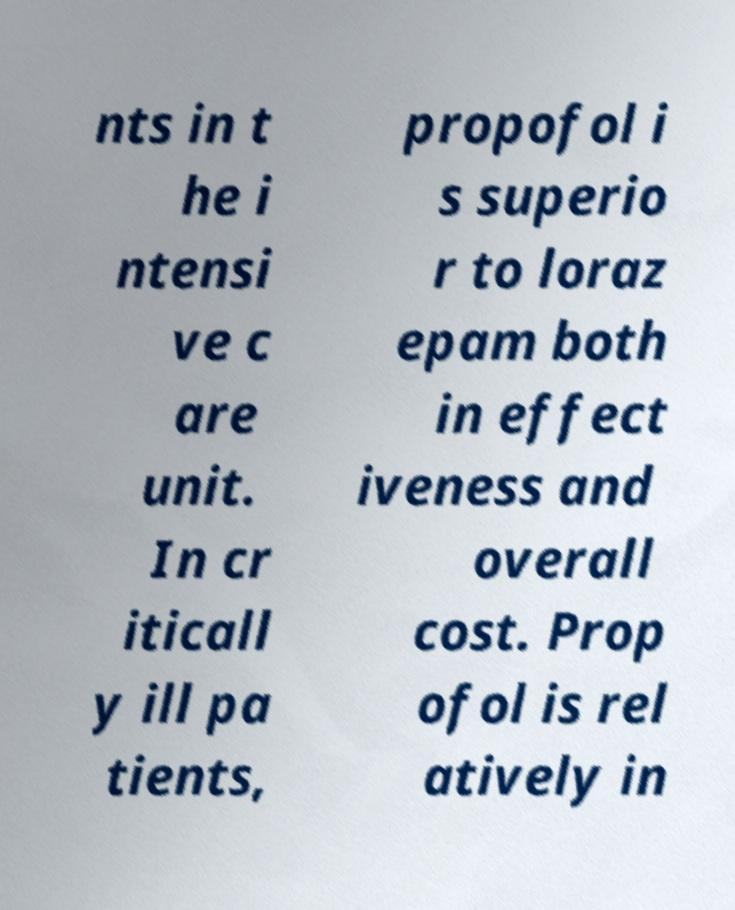For documentation purposes, I need the text within this image transcribed. Could you provide that? nts in t he i ntensi ve c are unit. In cr iticall y ill pa tients, propofol i s superio r to loraz epam both in effect iveness and overall cost. Prop ofol is rel atively in 